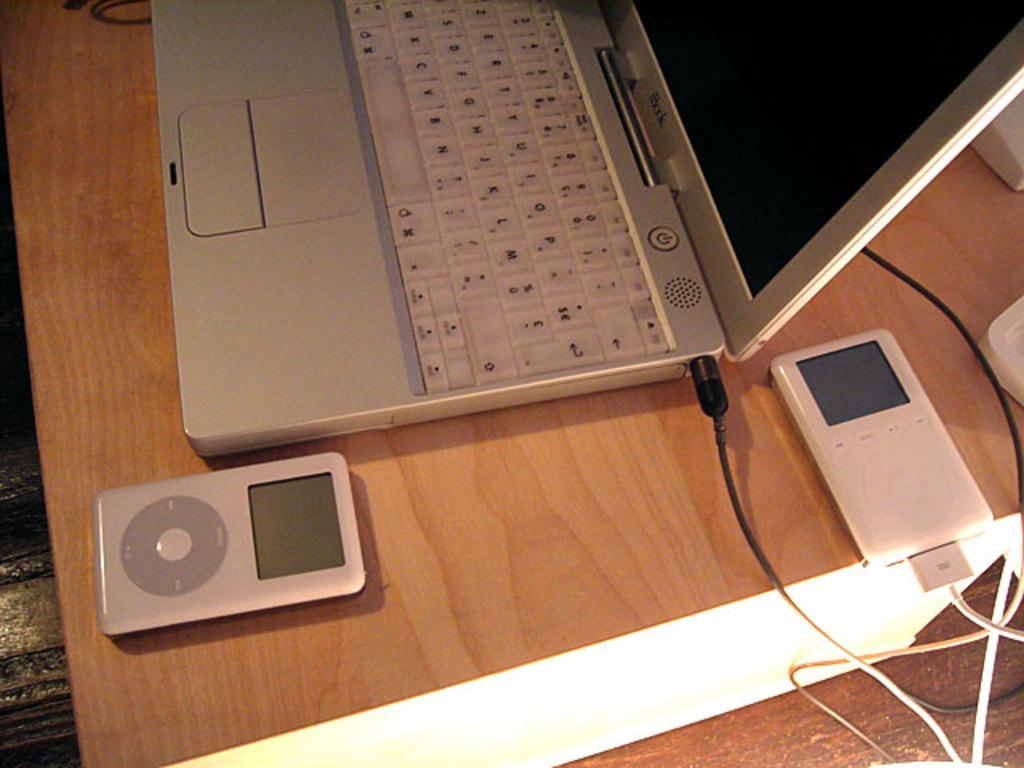What electronic device is visible in the image? There is a laptop in the image. What else can be seen in the image besides the laptop? Wires are visible in the image. What is the location of the electronic devices in the image? The electronic devices are on the table in the image. Can you hear the laptop laughing in the image? There is no sound or indication of laughter in the image; it is a still image of a laptop and wires. 